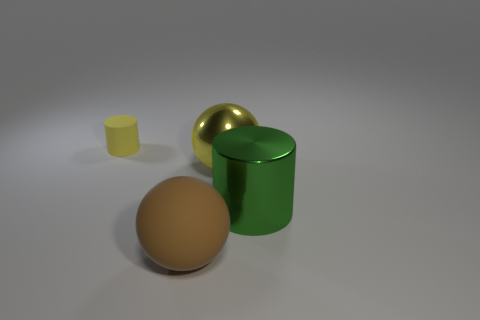Add 4 yellow matte cylinders. How many objects exist? 8 Subtract all big green things. Subtract all green objects. How many objects are left? 2 Add 3 large green metallic objects. How many large green metallic objects are left? 4 Add 4 big yellow metallic spheres. How many big yellow metallic spheres exist? 5 Subtract 0 gray cubes. How many objects are left? 4 